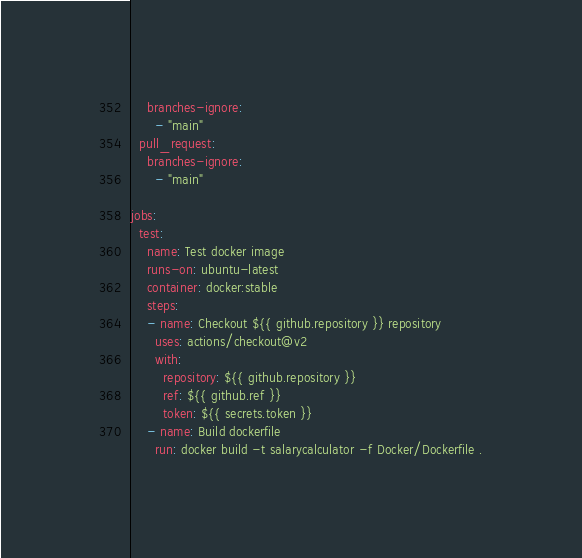<code> <loc_0><loc_0><loc_500><loc_500><_YAML_>    branches-ignore:
      - "main"
  pull_request:
    branches-ignore:
      - "main"

jobs:
  test:
    name: Test docker image
    runs-on: ubuntu-latest
    container: docker:stable
    steps:
    - name: Checkout ${{ github.repository }} repository
      uses: actions/checkout@v2
      with:
        repository: ${{ github.repository }}
        ref: ${{ github.ref }}
        token: ${{ secrets.token }}
    - name: Build dockerfile
      run: docker build -t salarycalculator -f Docker/Dockerfile .
</code> 